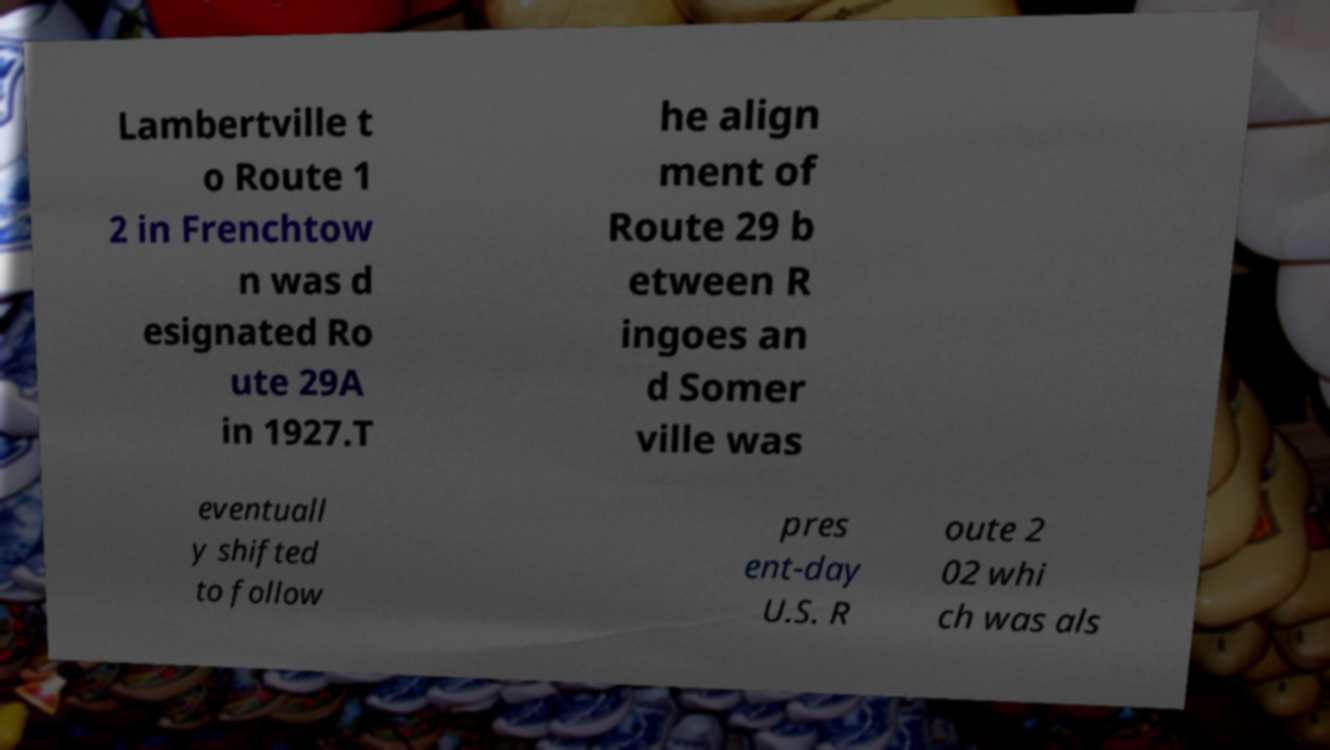What messages or text are displayed in this image? I need them in a readable, typed format. Lambertville t o Route 1 2 in Frenchtow n was d esignated Ro ute 29A in 1927.T he align ment of Route 29 b etween R ingoes an d Somer ville was eventuall y shifted to follow pres ent-day U.S. R oute 2 02 whi ch was als 